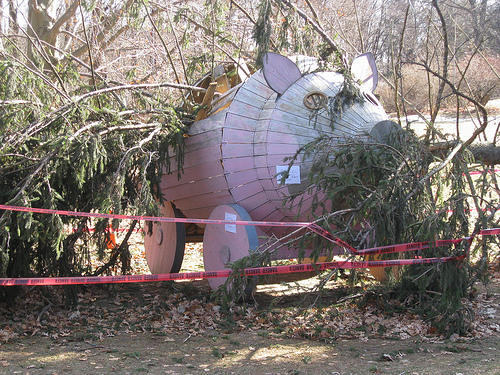<image>
Can you confirm if the tree is in the pig? Yes. The tree is contained within or inside the pig, showing a containment relationship. 